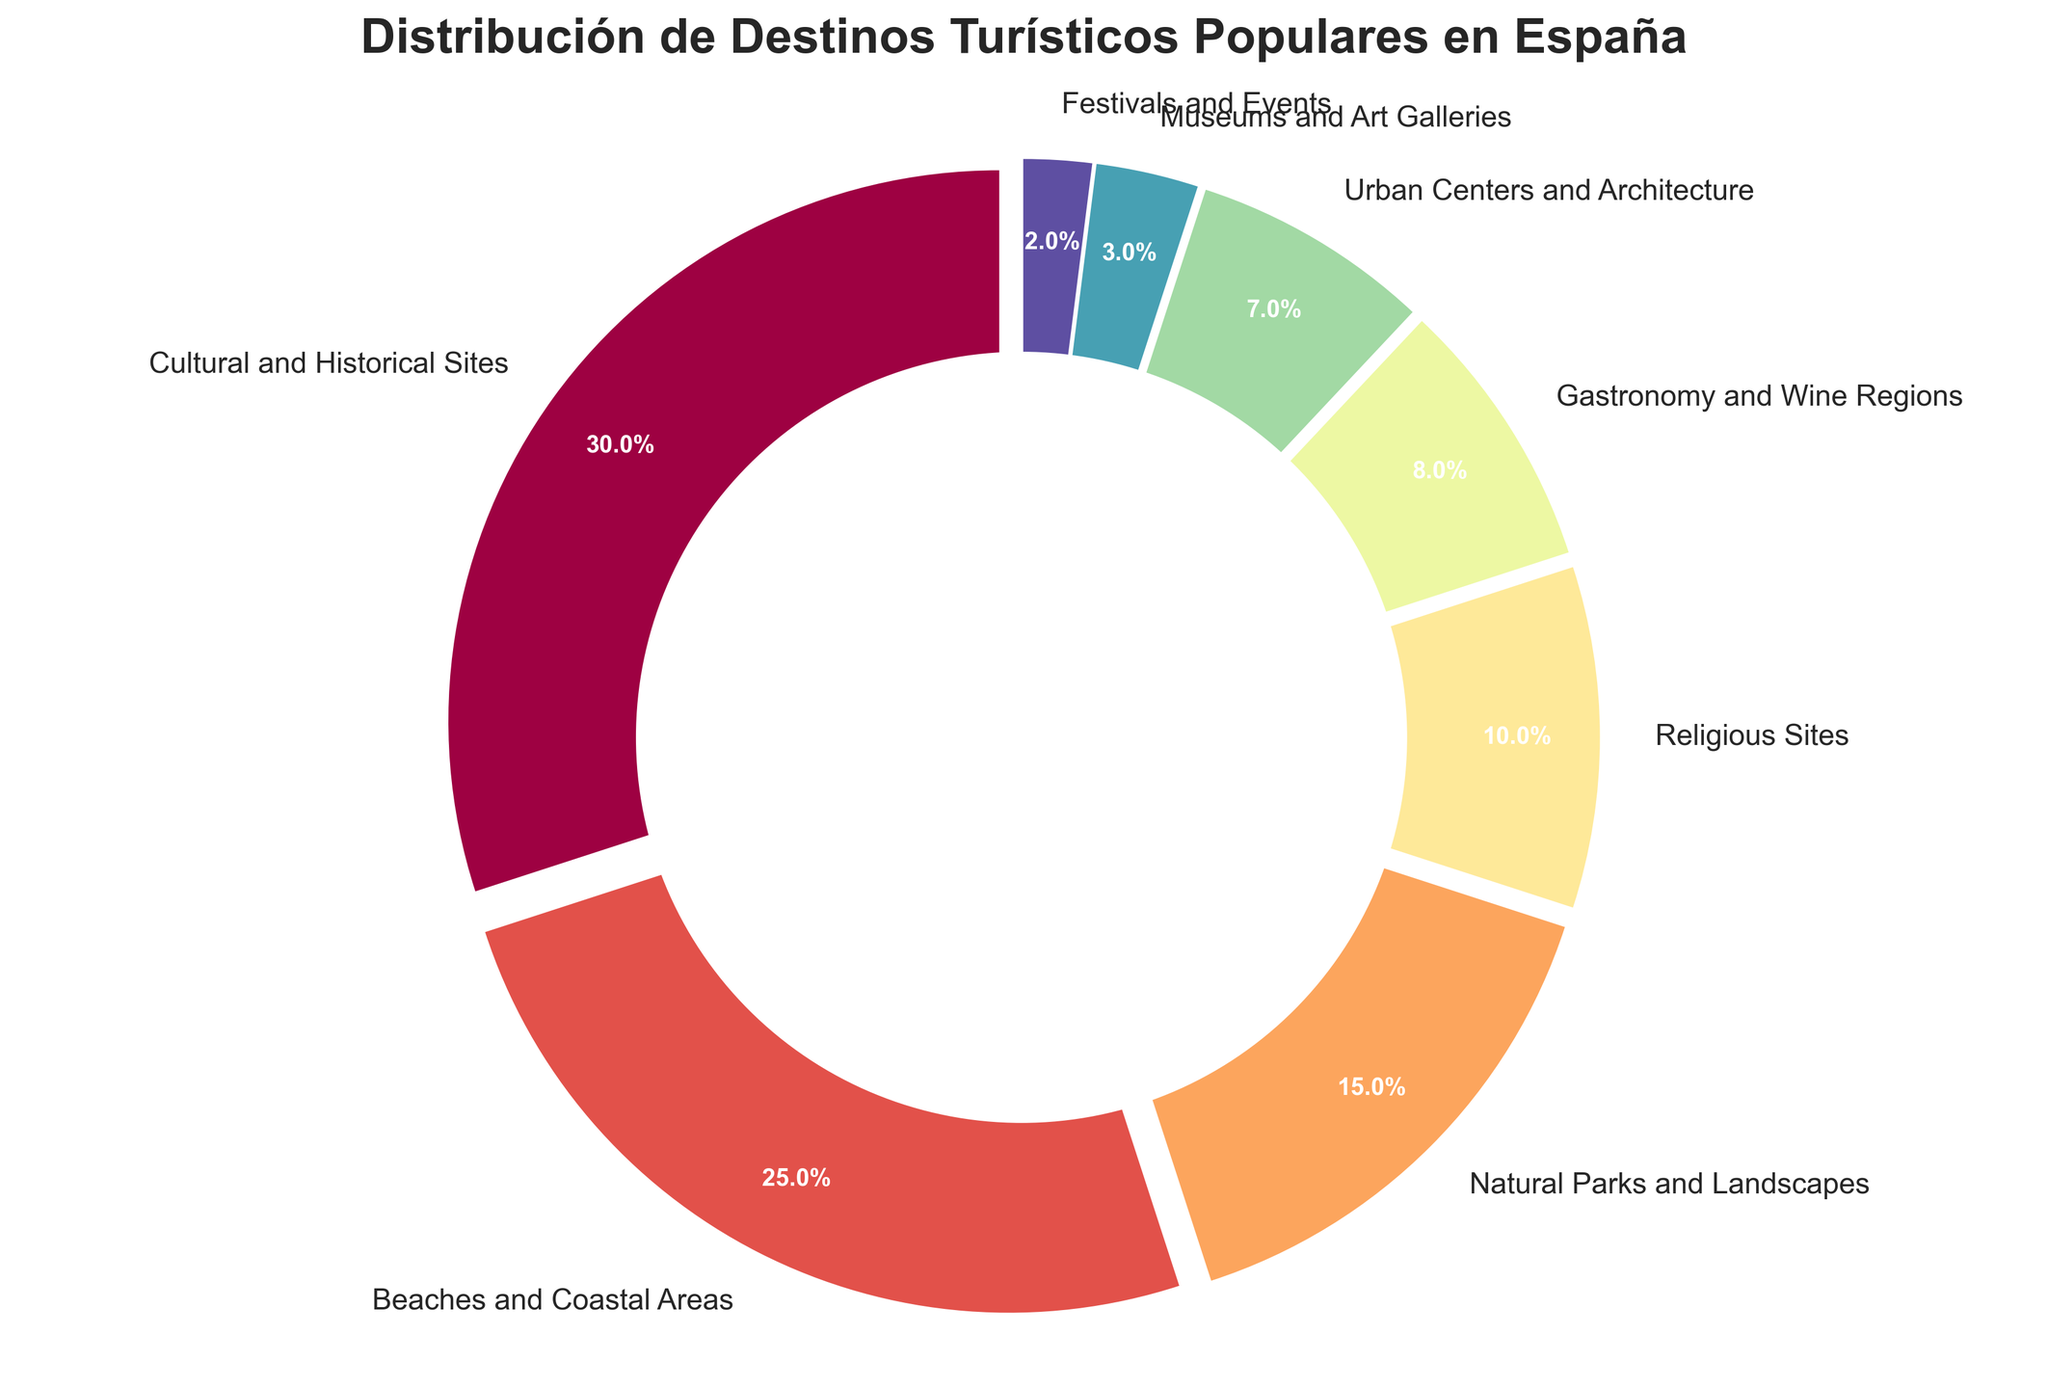Which type of attraction has the highest percentage? The cultural and historical sites have the highest percentage. This can be directly seen from the chart as they occupy the largest portion of the pie chart.
Answer: Cultural and Historical Sites Which type of attraction has the smallest percentage? Festivals and events have the smallest percentage at 2%. This is evident from the figure as they occupy the smallest slice of the pie chart.
Answer: Festivals and Events How much larger is the percentage of cultural and historical sites compared to museums and art galleries? The percentage of cultural and historical sites is 30%, and museums and art galleries have 3%. The difference between them is 30% - 3% = 27%.
Answer: 27% What percentage of attractions are natural parks and landscapes? The portion of the pie labeled as natural parks and landscapes occupies 15% of the chart, as indicated by the label.
Answer: 15% How do beaches and coastal areas compare to gastronomy and wine regions in terms of percentage? Beaches and coastal areas occupy 25% of the chart, while gastronomy and wine regions occupy 8%. Therefore, beaches and coastal areas have a higher percentage.
Answer: Beaches and Coastal Areas have a higher percentage What is the combined percentage of urban centers and architecture, and museums and art galleries? Urban centers and architecture have a percentage of 7%, and museums and art galleries have 3%. Their combined percentage is 7% + 3% = 10%.
Answer: 10% If you combine the percentages of religious sites, gastronomy and wine regions, and festivals and events, what total percentage do you get? Religious sites have 10%, gastronomy and wine regions have 8%, and festivals and events have 2%. Combined, they amount to 10% + 8% + 2% = 20%.
Answer: 20% Rank the types of attractions from highest to lowest percentage. Looking at the chart, the ranking from highest to lowest percentage is: Cultural and Historical Sites, Beaches and Coastal Areas, Natural Parks and Landscapes, Religious Sites, Gastronomy and Wine Regions, Urban Centers and Architecture, Museums and Art Galleries, Festivals and Events.
Answer: Cultural and Historical Sites, Beaches and Coastal Areas, Natural Parks and Landscapes, Religious Sites, Gastronomy and Wine Regions, Urban Centers and Architecture, Museums and Art Galleries, Festivals and Events What percentage of attractions are either cultural and historical sites or beaches and coastal areas? Combining the percentages of cultural and historical sites (30%) and beaches and coastal areas (25%), we get 30% + 25% = 55%.
Answer: 55% How does the combined percentage of urban centers and architecture, and natural parks and landscapes compare to cultural and historical sites alone? Urban centers and architecture are 7% and natural parks and landscapes are 15%, combined they are 7% + 15% = 22%. Cultural and historical sites alone are 30%. Hence, cultural and historical sites have a higher percentage.
Answer: Cultural and Historical Sites have a higher percentage 